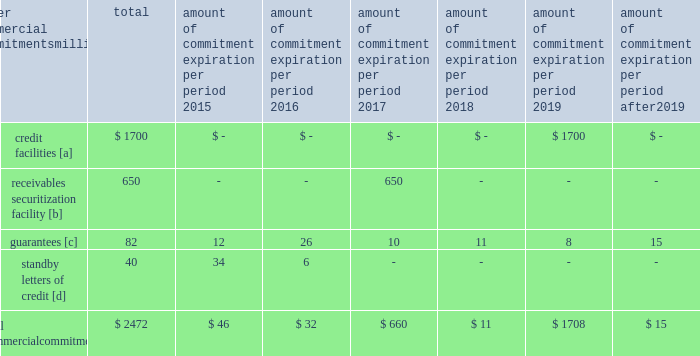Amount of commitment expiration per period other commercial commitments after millions total 2015 2016 2017 2018 2019 2019 .
[a] none of the credit facility was used as of december 31 , 2014 .
[b] $ 400 million of the receivables securitization facility was utilized as of december 31 , 2014 , which is accounted for as debt .
The full program matures in july 2017 .
[c] includes guaranteed obligations related to our equipment financings and affiliated operations .
[d] none of the letters of credit were drawn upon as of december 31 , 2014 .
Off-balance sheet arrangements guarantees 2013 at december 31 , 2014 , and 2013 , we were contingently liable for $ 82 million and $ 299 million in guarantees .
We have recorded liabilities of $ 0.3 million and $ 1 million for the fair value of these obligations as of december 31 , 2014 , and 2013 , respectively .
We entered into these contingent guarantees in the normal course of business , and they include guaranteed obligations related to our equipment financings and affiliated operations .
The final guarantee expires in 2022 .
We are not aware of any existing event of default that would require us to satisfy these guarantees .
We do not expect that these guarantees will have a material adverse effect on our consolidated financial condition , results of operations , or liquidity .
Other matters labor agreements 2013 approximately 85% ( 85 % ) of our 47201 full-time-equivalent employees are represented by 14 major rail unions .
On january 1 , 2015 , current labor agreements became subject to modification and we began the current round of negotiations with the unions .
Existing agreements remain in effect until new agreements are reached or the railway labor act 2019s procedures ( which include mediation , cooling-off periods , and the possibility of presidential emergency boards and congressional intervention ) are exhausted .
Contract negotiations historically continue for an extended period of time and we rarely experience work stoppages while negotiations are pending .
Inflation 2013 long periods of inflation significantly increase asset replacement costs for capital-intensive companies .
As a result , assuming that we replace all operating assets at current price levels , depreciation charges ( on an inflation-adjusted basis ) would be substantially greater than historically reported amounts .
Derivative financial instruments 2013 we may use derivative financial instruments in limited instances to assist in managing our overall exposure to fluctuations in interest rates and fuel prices .
We are not a party to leveraged derivatives and , by policy , do not use derivative financial instruments for speculative purposes .
Derivative financial instruments qualifying for hedge accounting must maintain a specified level of effectiveness between the hedging instrument and the item being hedged , both at inception and throughout the hedged period .
We formally document the nature and relationships between the hedging instruments and hedged items at inception , as well as our risk-management objectives , strategies for undertaking the various hedge transactions , and method of assessing hedge effectiveness .
Changes in the fair market value of derivative financial instruments that do not qualify for hedge accounting are charged to earnings .
We may use swaps , collars , futures , and/or forward contracts to mitigate the risk of adverse movements in interest rates and fuel prices ; however , the use of these derivative financial instruments may limit future benefits from favorable price movements .
Market and credit risk 2013 we address market risk related to derivative financial instruments by selecting instruments with value fluctuations that highly correlate with the underlying hedged item .
We manage credit risk related to derivative financial instruments , which is minimal , by requiring high credit standards for counterparties and periodic settlements .
At december 31 , 2014 and 2013 , we were not required to provide collateral , nor had we received collateral , relating to our hedging activities. .
What percent of total commitments are greater than 5 years? 
Computations: (15 / 2472)
Answer: 0.00607. 